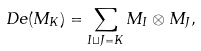Convert formula to latex. <formula><loc_0><loc_0><loc_500><loc_500>\ D e ( M _ { K } ) = \sum _ { I \sqcup J = K } M _ { I } \otimes M _ { J } ,</formula> 